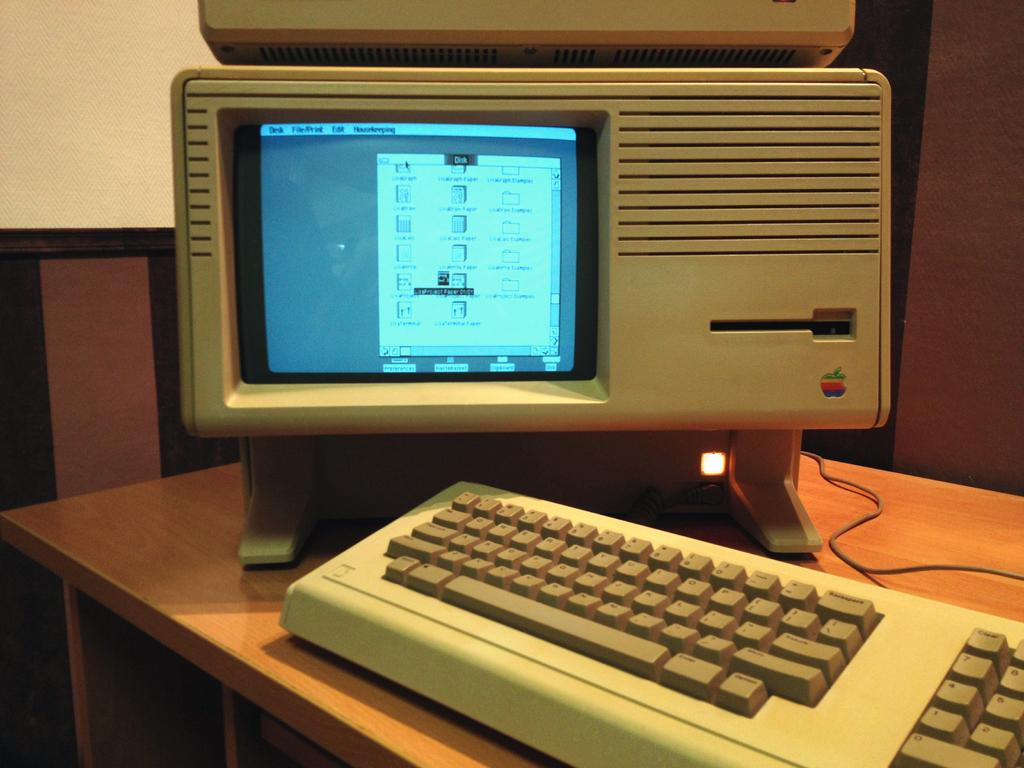<image>
Write a terse but informative summary of the picture. An old computer displays a window on the monitor that is titled "disk." 